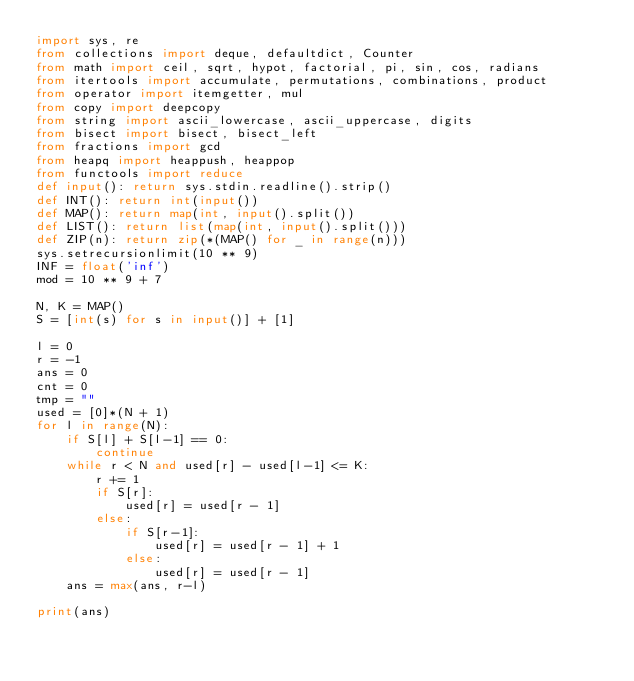Convert code to text. <code><loc_0><loc_0><loc_500><loc_500><_Python_>import sys, re
from collections import deque, defaultdict, Counter
from math import ceil, sqrt, hypot, factorial, pi, sin, cos, radians
from itertools import accumulate, permutations, combinations, product
from operator import itemgetter, mul
from copy import deepcopy
from string import ascii_lowercase, ascii_uppercase, digits
from bisect import bisect, bisect_left
from fractions import gcd
from heapq import heappush, heappop
from functools import reduce
def input(): return sys.stdin.readline().strip()
def INT(): return int(input())
def MAP(): return map(int, input().split())
def LIST(): return list(map(int, input().split()))
def ZIP(n): return zip(*(MAP() for _ in range(n)))
sys.setrecursionlimit(10 ** 9)
INF = float('inf')
mod = 10 ** 9 + 7

N, K = MAP()
S = [int(s) for s in input()] + [1]

l = 0
r = -1
ans = 0
cnt = 0
tmp = ""
used = [0]*(N + 1)
for l in range(N):
    if S[l] + S[l-1] == 0:
        continue
    while r < N and used[r] - used[l-1] <= K:
        r += 1
        if S[r]:
            used[r] = used[r - 1]
        else:
            if S[r-1]:
                used[r] = used[r - 1] + 1
            else:
                used[r] = used[r - 1]
    ans = max(ans, r-l)

print(ans)
</code> 